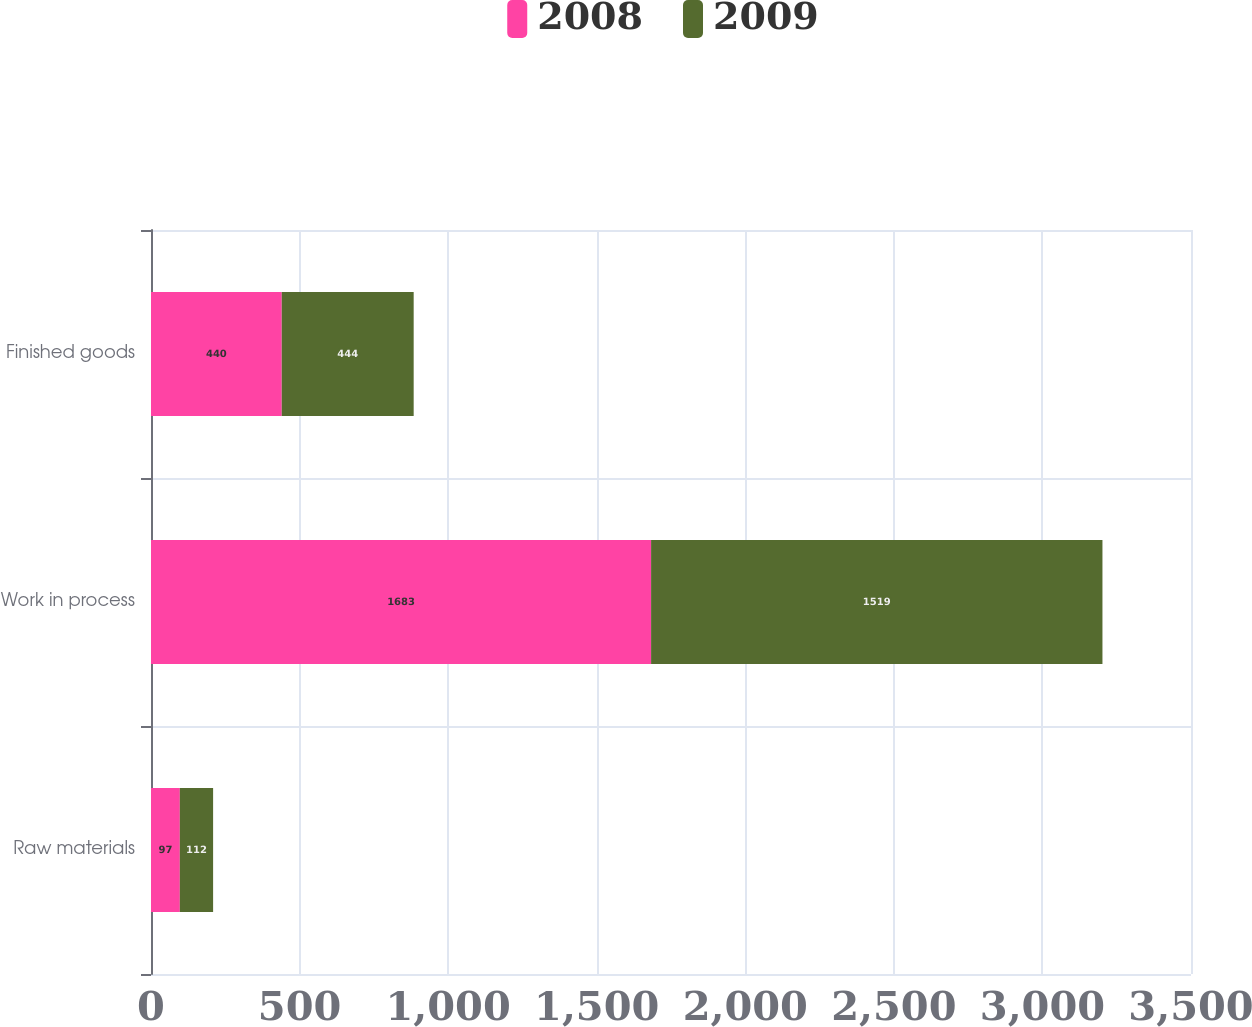Convert chart. <chart><loc_0><loc_0><loc_500><loc_500><stacked_bar_chart><ecel><fcel>Raw materials<fcel>Work in process<fcel>Finished goods<nl><fcel>2008<fcel>97<fcel>1683<fcel>440<nl><fcel>2009<fcel>112<fcel>1519<fcel>444<nl></chart> 